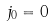<formula> <loc_0><loc_0><loc_500><loc_500>j _ { 0 } = 0</formula> 